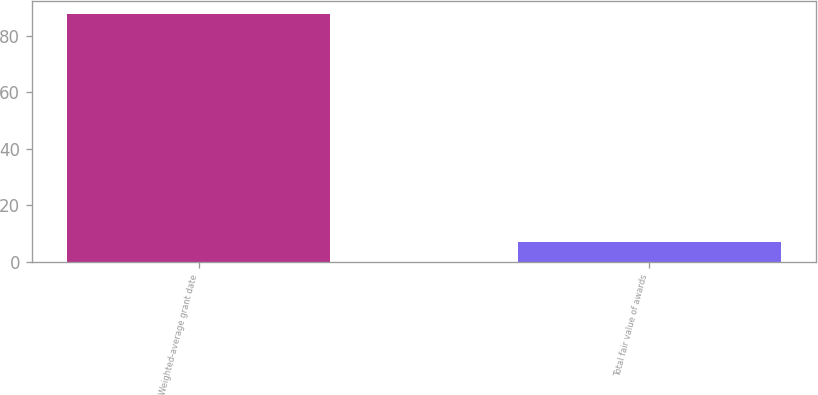Convert chart to OTSL. <chart><loc_0><loc_0><loc_500><loc_500><bar_chart><fcel>Weighted-average grant date<fcel>Total fair value of awards<nl><fcel>87.85<fcel>7.1<nl></chart> 